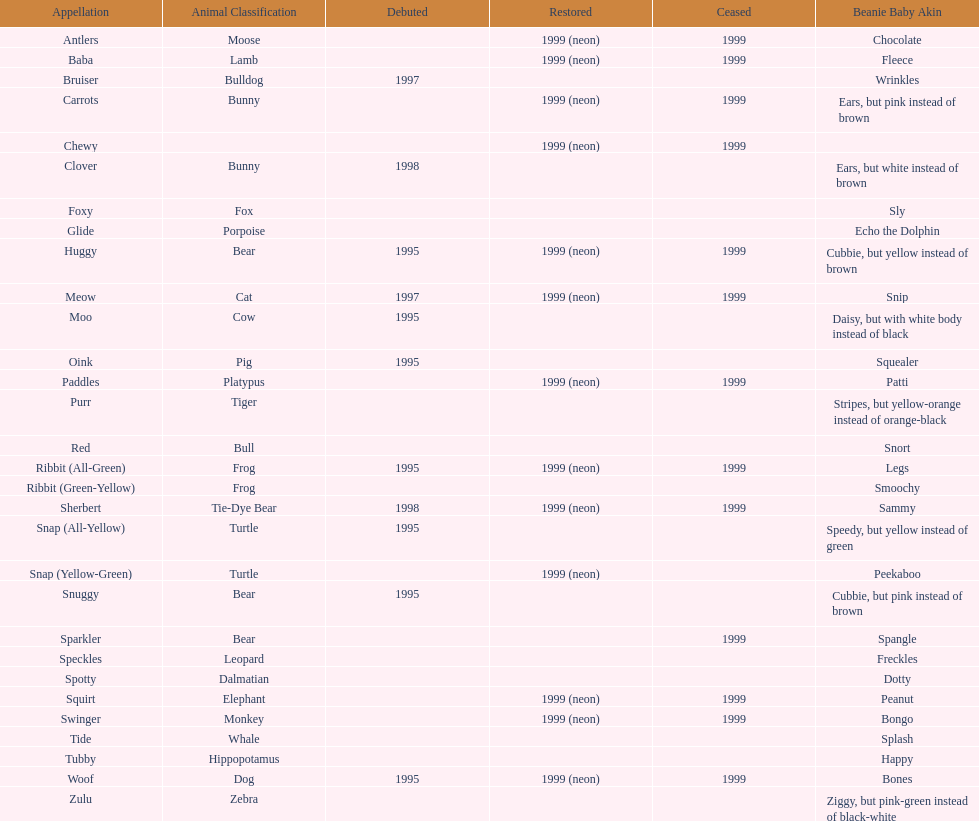What is the number of frog pillow pals? 2. I'm looking to parse the entire table for insights. Could you assist me with that? {'header': ['Appellation', 'Animal Classification', 'Debuted', 'Restored', 'Ceased', 'Beanie Baby Akin'], 'rows': [['Antlers', 'Moose', '', '1999 (neon)', '1999', 'Chocolate'], ['Baba', 'Lamb', '', '1999 (neon)', '1999', 'Fleece'], ['Bruiser', 'Bulldog', '1997', '', '', 'Wrinkles'], ['Carrots', 'Bunny', '', '1999 (neon)', '1999', 'Ears, but pink instead of brown'], ['Chewy', '', '', '1999 (neon)', '1999', ''], ['Clover', 'Bunny', '1998', '', '', 'Ears, but white instead of brown'], ['Foxy', 'Fox', '', '', '', 'Sly'], ['Glide', 'Porpoise', '', '', '', 'Echo the Dolphin'], ['Huggy', 'Bear', '1995', '1999 (neon)', '1999', 'Cubbie, but yellow instead of brown'], ['Meow', 'Cat', '1997', '1999 (neon)', '1999', 'Snip'], ['Moo', 'Cow', '1995', '', '', 'Daisy, but with white body instead of black'], ['Oink', 'Pig', '1995', '', '', 'Squealer'], ['Paddles', 'Platypus', '', '1999 (neon)', '1999', 'Patti'], ['Purr', 'Tiger', '', '', '', 'Stripes, but yellow-orange instead of orange-black'], ['Red', 'Bull', '', '', '', 'Snort'], ['Ribbit (All-Green)', 'Frog', '1995', '1999 (neon)', '1999', 'Legs'], ['Ribbit (Green-Yellow)', 'Frog', '', '', '', 'Smoochy'], ['Sherbert', 'Tie-Dye Bear', '1998', '1999 (neon)', '1999', 'Sammy'], ['Snap (All-Yellow)', 'Turtle', '1995', '', '', 'Speedy, but yellow instead of green'], ['Snap (Yellow-Green)', 'Turtle', '', '1999 (neon)', '', 'Peekaboo'], ['Snuggy', 'Bear', '1995', '', '', 'Cubbie, but pink instead of brown'], ['Sparkler', 'Bear', '', '', '1999', 'Spangle'], ['Speckles', 'Leopard', '', '', '', 'Freckles'], ['Spotty', 'Dalmatian', '', '', '', 'Dotty'], ['Squirt', 'Elephant', '', '1999 (neon)', '1999', 'Peanut'], ['Swinger', 'Monkey', '', '1999 (neon)', '1999', 'Bongo'], ['Tide', 'Whale', '', '', '', 'Splash'], ['Tubby', 'Hippopotamus', '', '', '', 'Happy'], ['Woof', 'Dog', '1995', '1999 (neon)', '1999', 'Bones'], ['Zulu', 'Zebra', '', '', '', 'Ziggy, but pink-green instead of black-white']]} 